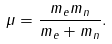Convert formula to latex. <formula><loc_0><loc_0><loc_500><loc_500>\mu = \frac { m _ { e } m _ { n } } { m _ { e } + m _ { n } } .</formula> 